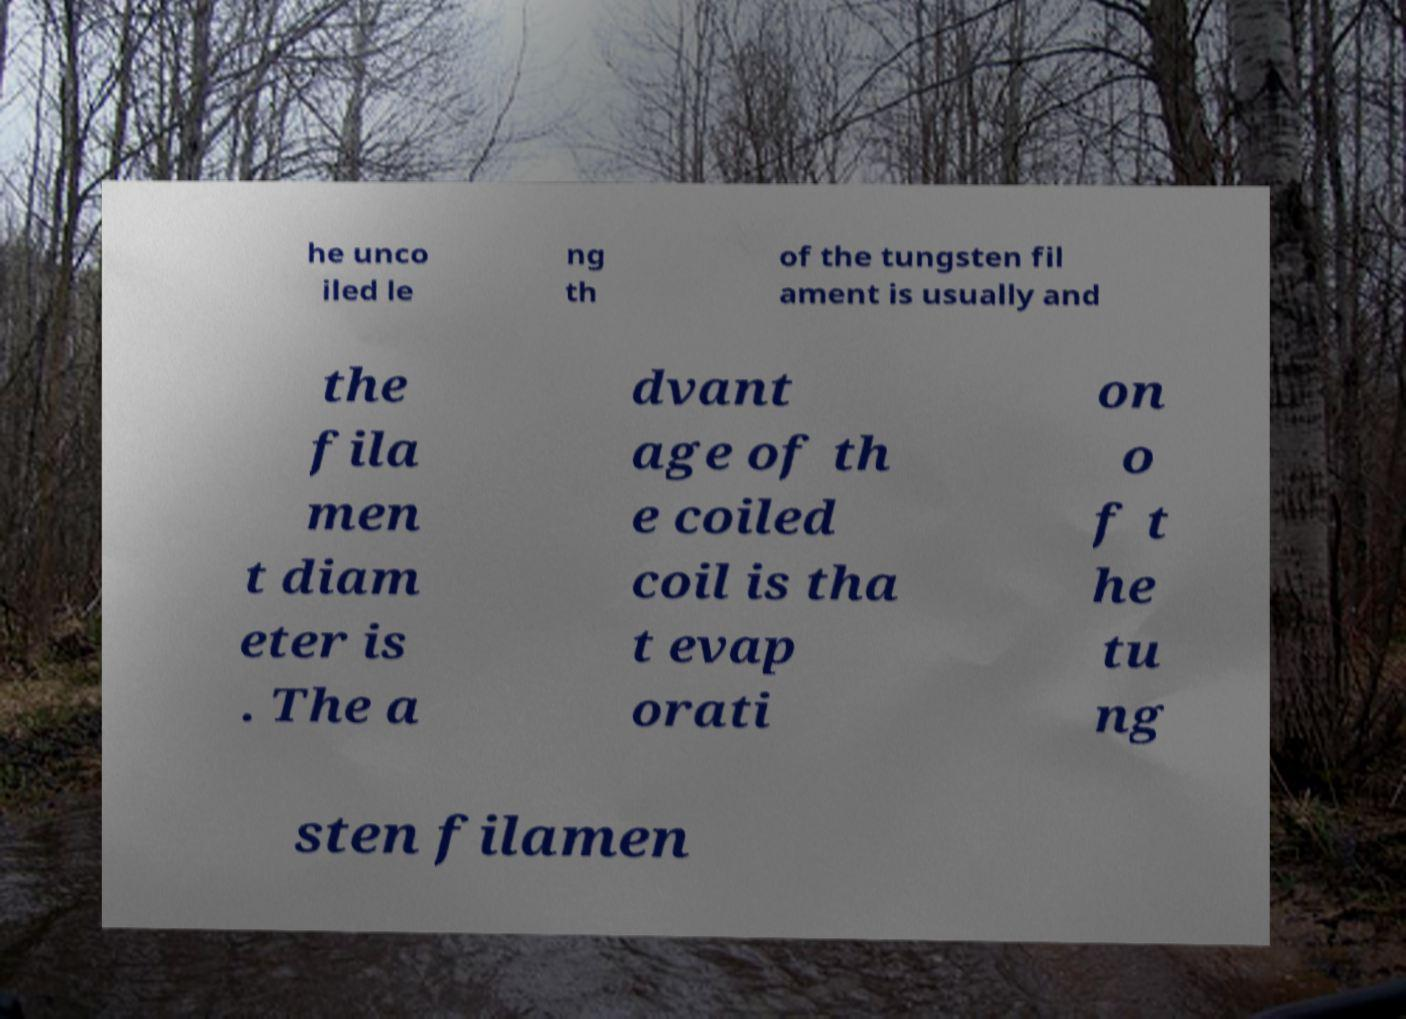Could you assist in decoding the text presented in this image and type it out clearly? he unco iled le ng th of the tungsten fil ament is usually and the fila men t diam eter is . The a dvant age of th e coiled coil is tha t evap orati on o f t he tu ng sten filamen 